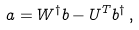Convert formula to latex. <formula><loc_0><loc_0><loc_500><loc_500>a = W ^ { \dagger } b - U ^ { T } b ^ { \dagger } \, ,</formula> 